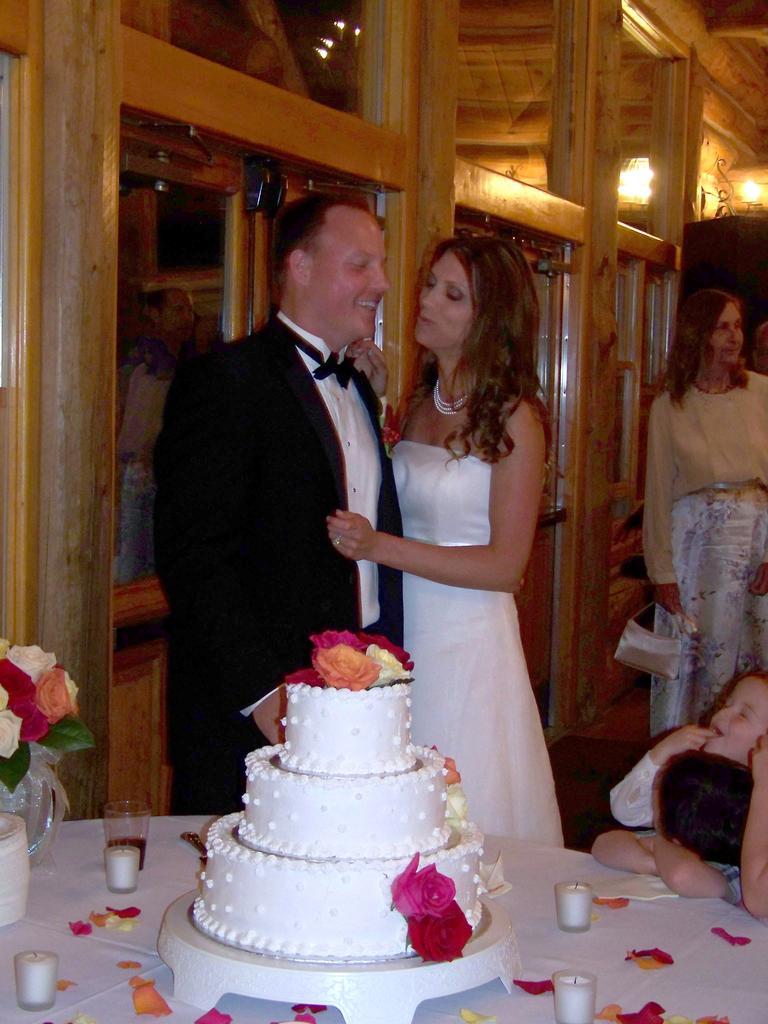Describe this image in one or two sentences. This is the man and woman standing. I can see a table covered with a cloth. These are the candles, glass, flower vase with the flowers, rose petals and a cake are placed on the table. There are two kids and a woman standing. This looks like a lamp. These are the glass doors with the wooden frames. 